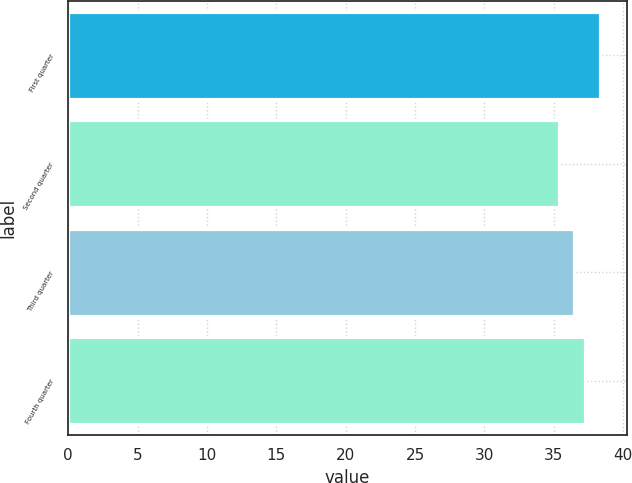<chart> <loc_0><loc_0><loc_500><loc_500><bar_chart><fcel>First quarter<fcel>Second quarter<fcel>Third quarter<fcel>Fourth quarter<nl><fcel>38.35<fcel>35.35<fcel>36.48<fcel>37.25<nl></chart> 